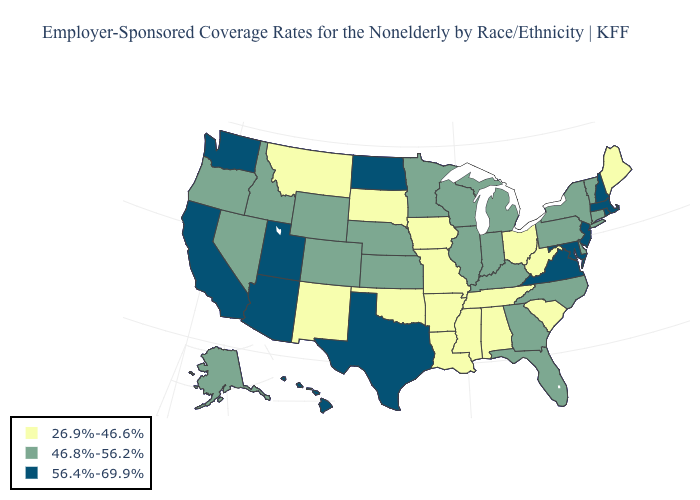Name the states that have a value in the range 26.9%-46.6%?
Quick response, please. Alabama, Arkansas, Iowa, Louisiana, Maine, Mississippi, Missouri, Montana, New Mexico, Ohio, Oklahoma, South Carolina, South Dakota, Tennessee, West Virginia. What is the value of Minnesota?
Answer briefly. 46.8%-56.2%. Does New Mexico have the highest value in the West?
Give a very brief answer. No. Among the states that border New Jersey , which have the highest value?
Keep it brief. Delaware, New York, Pennsylvania. Does the map have missing data?
Keep it brief. No. Does the map have missing data?
Answer briefly. No. Does Utah have a higher value than Massachusetts?
Answer briefly. No. Does Tennessee have the lowest value in the USA?
Answer briefly. Yes. How many symbols are there in the legend?
Short answer required. 3. Name the states that have a value in the range 46.8%-56.2%?
Answer briefly. Alaska, Colorado, Connecticut, Delaware, Florida, Georgia, Idaho, Illinois, Indiana, Kansas, Kentucky, Michigan, Minnesota, Nebraska, Nevada, New York, North Carolina, Oregon, Pennsylvania, Vermont, Wisconsin, Wyoming. Name the states that have a value in the range 46.8%-56.2%?
Quick response, please. Alaska, Colorado, Connecticut, Delaware, Florida, Georgia, Idaho, Illinois, Indiana, Kansas, Kentucky, Michigan, Minnesota, Nebraska, Nevada, New York, North Carolina, Oregon, Pennsylvania, Vermont, Wisconsin, Wyoming. Name the states that have a value in the range 46.8%-56.2%?
Short answer required. Alaska, Colorado, Connecticut, Delaware, Florida, Georgia, Idaho, Illinois, Indiana, Kansas, Kentucky, Michigan, Minnesota, Nebraska, Nevada, New York, North Carolina, Oregon, Pennsylvania, Vermont, Wisconsin, Wyoming. Does the map have missing data?
Concise answer only. No. Among the states that border Pennsylvania , which have the lowest value?
Give a very brief answer. Ohio, West Virginia. Does Alaska have the lowest value in the West?
Answer briefly. No. 